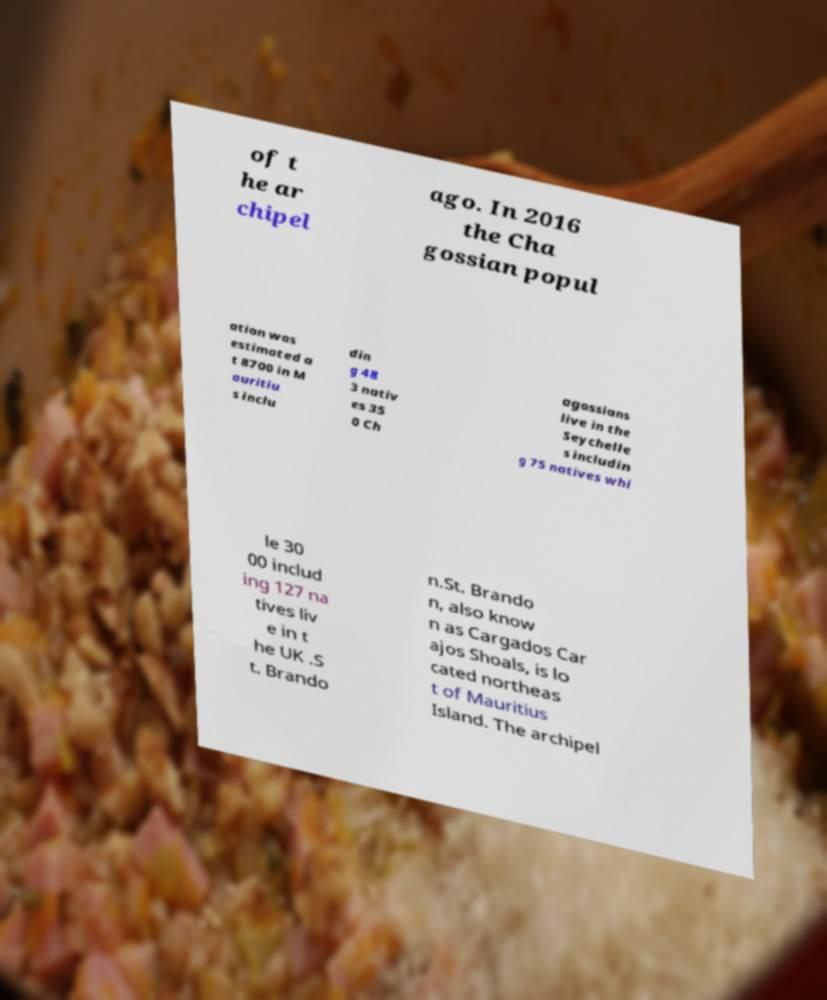There's text embedded in this image that I need extracted. Can you transcribe it verbatim? of t he ar chipel ago. In 2016 the Cha gossian popul ation was estimated a t 8700 in M auritiu s inclu din g 48 3 nativ es 35 0 Ch agossians live in the Seychelle s includin g 75 natives whi le 30 00 includ ing 127 na tives liv e in t he UK .S t. Brando n.St. Brando n, also know n as Cargados Car ajos Shoals, is lo cated northeas t of Mauritius Island. The archipel 